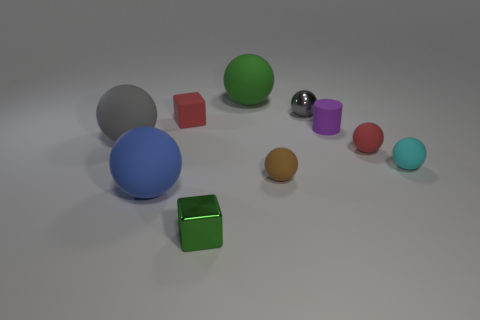What is the size of the blue object that is the same material as the brown sphere?
Your answer should be compact. Large. Are there any red matte objects behind the rubber cube?
Provide a succinct answer. No. Is the shape of the tiny cyan object the same as the purple thing?
Your response must be concise. No. There is a gray sphere that is in front of the small red object that is behind the gray thing on the left side of the tiny brown rubber ball; what is its size?
Provide a succinct answer. Large. What material is the big blue object?
Keep it short and to the point. Rubber. There is a thing that is the same color as the rubber block; what is its size?
Your answer should be compact. Small. There is a small gray object; is its shape the same as the red object that is on the left side of the small brown ball?
Provide a succinct answer. No. What is the material of the gray ball that is to the right of the gray object in front of the tiny metallic ball behind the tiny cyan ball?
Offer a very short reply. Metal. What number of big objects are there?
Give a very brief answer. 3. How many green objects are either large objects or tiny metallic spheres?
Your answer should be very brief. 1. 